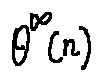<formula> <loc_0><loc_0><loc_500><loc_500>\theta ^ { \infty } ( n )</formula> 